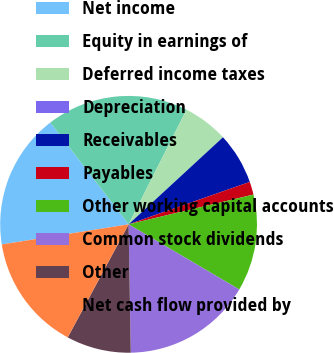Convert chart. <chart><loc_0><loc_0><loc_500><loc_500><pie_chart><fcel>Net income<fcel>Equity in earnings of<fcel>Deferred income taxes<fcel>Depreciation<fcel>Receivables<fcel>Payables<fcel>Other working capital accounts<fcel>Common stock dividends<fcel>Other<fcel>Net cash flow provided by<nl><fcel>17.07%<fcel>17.88%<fcel>5.69%<fcel>0.0%<fcel>6.5%<fcel>1.63%<fcel>12.19%<fcel>16.26%<fcel>8.13%<fcel>14.63%<nl></chart> 